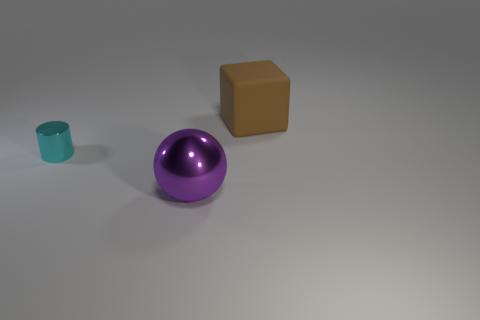There is a thing behind the cyan cylinder; does it have the same shape as the large thing that is in front of the tiny cylinder?
Offer a terse response. No. The thing to the right of the big thing left of the thing behind the metallic cylinder is what color?
Keep it short and to the point. Brown. There is a metal object that is behind the purple shiny object; what color is it?
Give a very brief answer. Cyan. What color is the ball that is the same size as the brown rubber block?
Make the answer very short. Purple. Do the matte thing and the cylinder have the same size?
Keep it short and to the point. No. There is a cyan metallic object; how many small cyan shiny things are behind it?
Your answer should be very brief. 0. What number of things are either big things that are behind the cyan cylinder or large blocks?
Make the answer very short. 1. Is the number of cylinders right of the small cyan object greater than the number of large purple metal things behind the purple metal sphere?
Your answer should be very brief. No. Is the size of the matte object the same as the shiny object left of the large purple sphere?
Provide a short and direct response. No. What number of cubes are large purple metallic objects or cyan shiny things?
Keep it short and to the point. 0. 